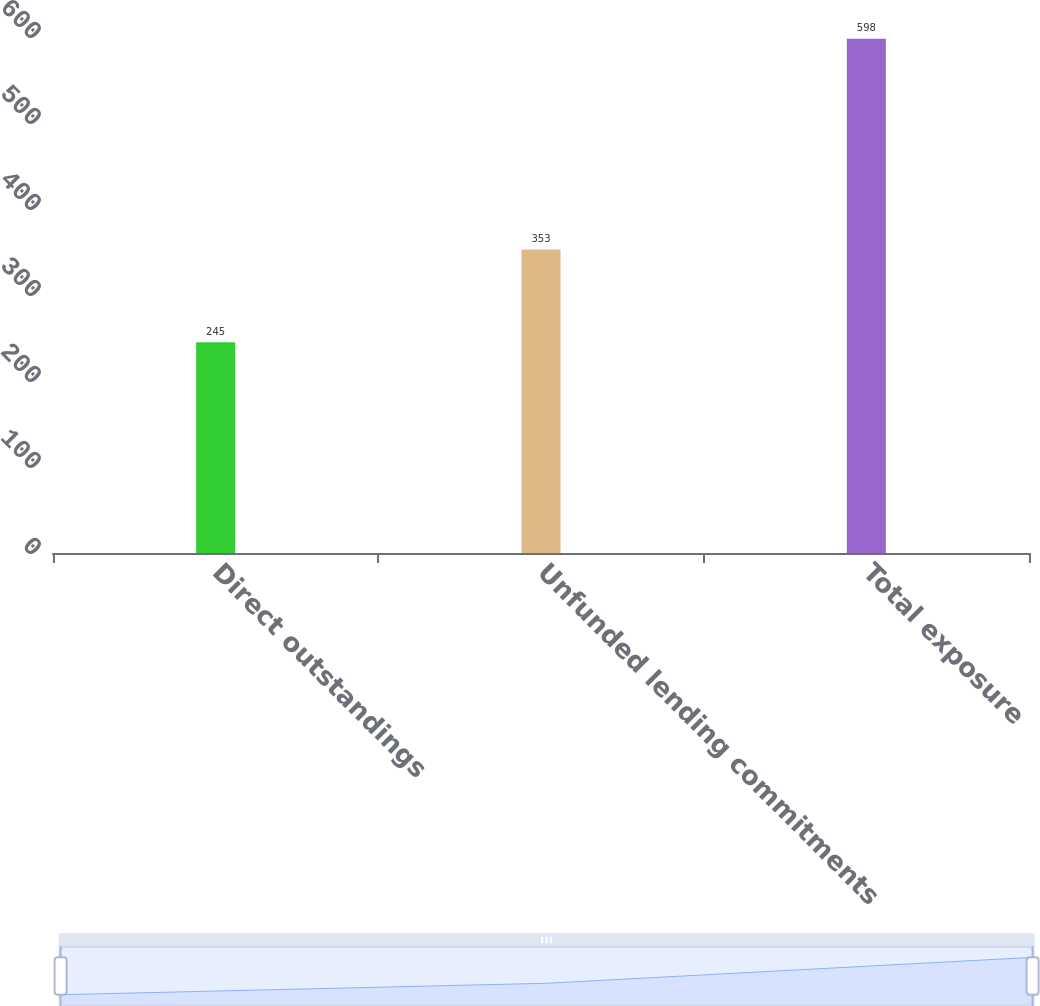<chart> <loc_0><loc_0><loc_500><loc_500><bar_chart><fcel>Direct outstandings<fcel>Unfunded lending commitments<fcel>Total exposure<nl><fcel>245<fcel>353<fcel>598<nl></chart> 